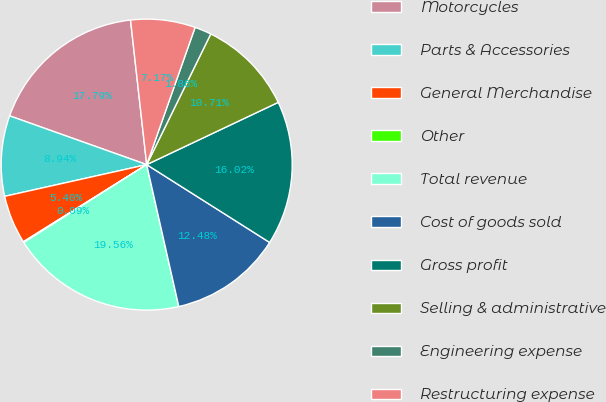<chart> <loc_0><loc_0><loc_500><loc_500><pie_chart><fcel>Motorcycles<fcel>Parts & Accessories<fcel>General Merchandise<fcel>Other<fcel>Total revenue<fcel>Cost of goods sold<fcel>Gross profit<fcel>Selling & administrative<fcel>Engineering expense<fcel>Restructuring expense<nl><fcel>17.79%<fcel>8.94%<fcel>5.4%<fcel>0.09%<fcel>19.56%<fcel>12.48%<fcel>16.02%<fcel>10.71%<fcel>1.86%<fcel>7.17%<nl></chart> 